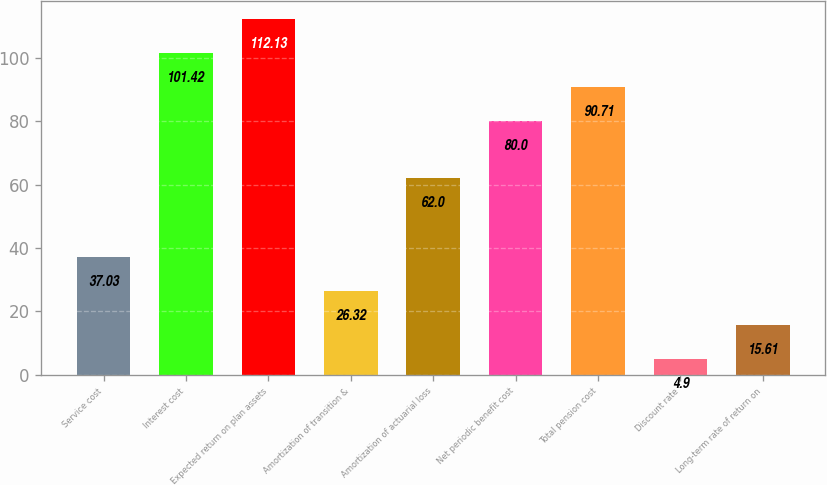<chart> <loc_0><loc_0><loc_500><loc_500><bar_chart><fcel>Service cost<fcel>Interest cost<fcel>Expected return on plan assets<fcel>Amortization of transition &<fcel>Amortization of actuarial loss<fcel>Net periodic benefit cost<fcel>Total pension cost<fcel>Discount rate<fcel>Long-term rate of return on<nl><fcel>37.03<fcel>101.42<fcel>112.13<fcel>26.32<fcel>62<fcel>80<fcel>90.71<fcel>4.9<fcel>15.61<nl></chart> 